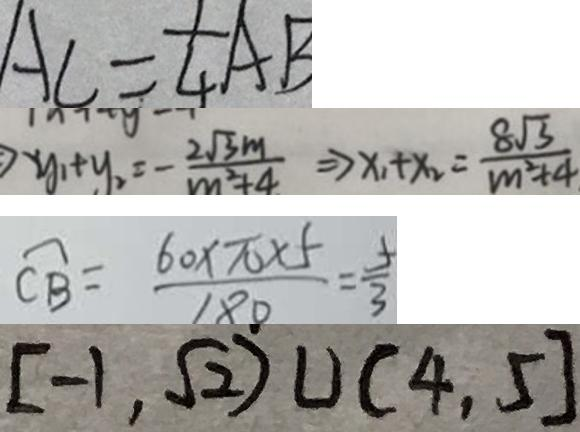Convert formula to latex. <formula><loc_0><loc_0><loc_500><loc_500>A C = \frac { 1 } { 4 } A B 
 y _ { 1 } + y _ { 2 } = - \frac { 2 \sqrt { 3 } m } { m ^ { 2 } + 4 } \rightarrow x _ { 1 } + x _ { 2 } = \frac { 8 \sqrt { 3 } } { m ^ { 2 } + 4 } 
 \widehat { C B } = \frac { 6 0 \times \pi \times 5 } { 1 8 0 } = \frac { 5 } { 3 } 
 [ - 1 , \sqrt { 2 } ) \cup ( 4 , 5 ]</formula> 